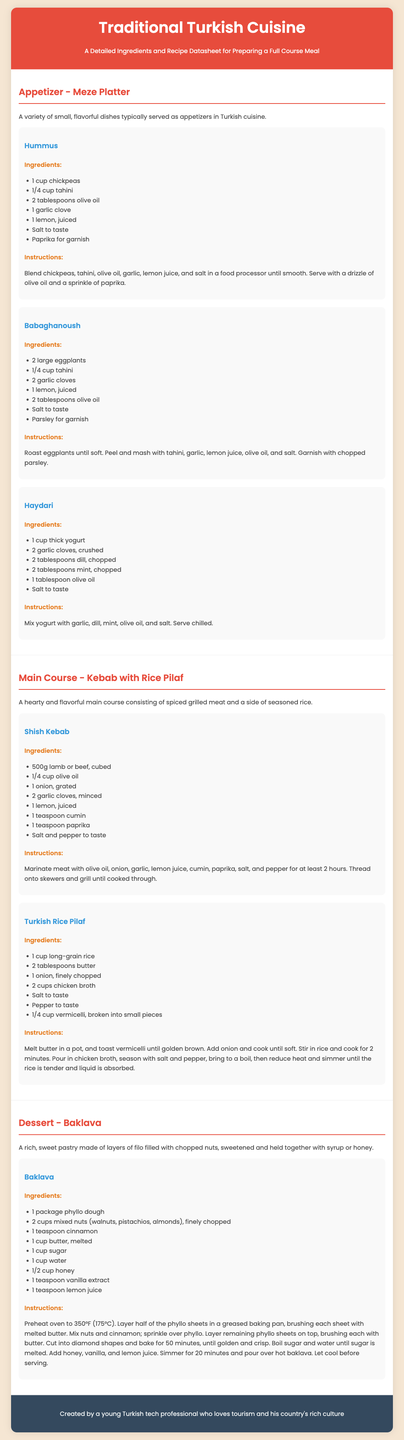What is the title of the datasheet? The title of the datasheet is mentioned at the top of the document.
Answer: Traditional Turkish Cuisine How many appetizers are listed in the document? The document contains a section for appetizers, which lists three specific dishes.
Answer: 3 What is the main ingredient in Hummus? The primary ingredient for Hummus is mentioned in the ingredients list.
Answer: Chickpeas What is the cooking time for Baklava? The cooking time for Baklava is indicated in the instructions.
Answer: 50 minutes What garnish is used for Babaghanoush? The garnish for Babaghanoush is specified in the ingredients section.
Answer: Parsley How long should the meat for Shish Kebab be marinated? The marination time for the meat in Shish Kebab is detailed in the instructions.
Answer: At least 2 hours What is the base for the Turkish Rice Pilaf? The primary base ingredient for the Turkish Rice Pilaf is stated clearly.
Answer: Long-grain rice What is used to sweeten Baklava? The sweetening agents for Baklava are listed in the ingredients section.
Answer: Sugar and honey 